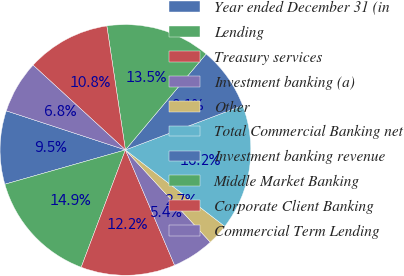Convert chart to OTSL. <chart><loc_0><loc_0><loc_500><loc_500><pie_chart><fcel>Year ended December 31 (in<fcel>Lending<fcel>Treasury services<fcel>Investment banking (a)<fcel>Other<fcel>Total Commercial Banking net<fcel>Investment banking revenue<fcel>Middle Market Banking<fcel>Corporate Client Banking<fcel>Commercial Term Lending<nl><fcel>9.46%<fcel>14.85%<fcel>12.15%<fcel>5.42%<fcel>2.73%<fcel>16.19%<fcel>8.11%<fcel>13.5%<fcel>10.81%<fcel>6.77%<nl></chart> 